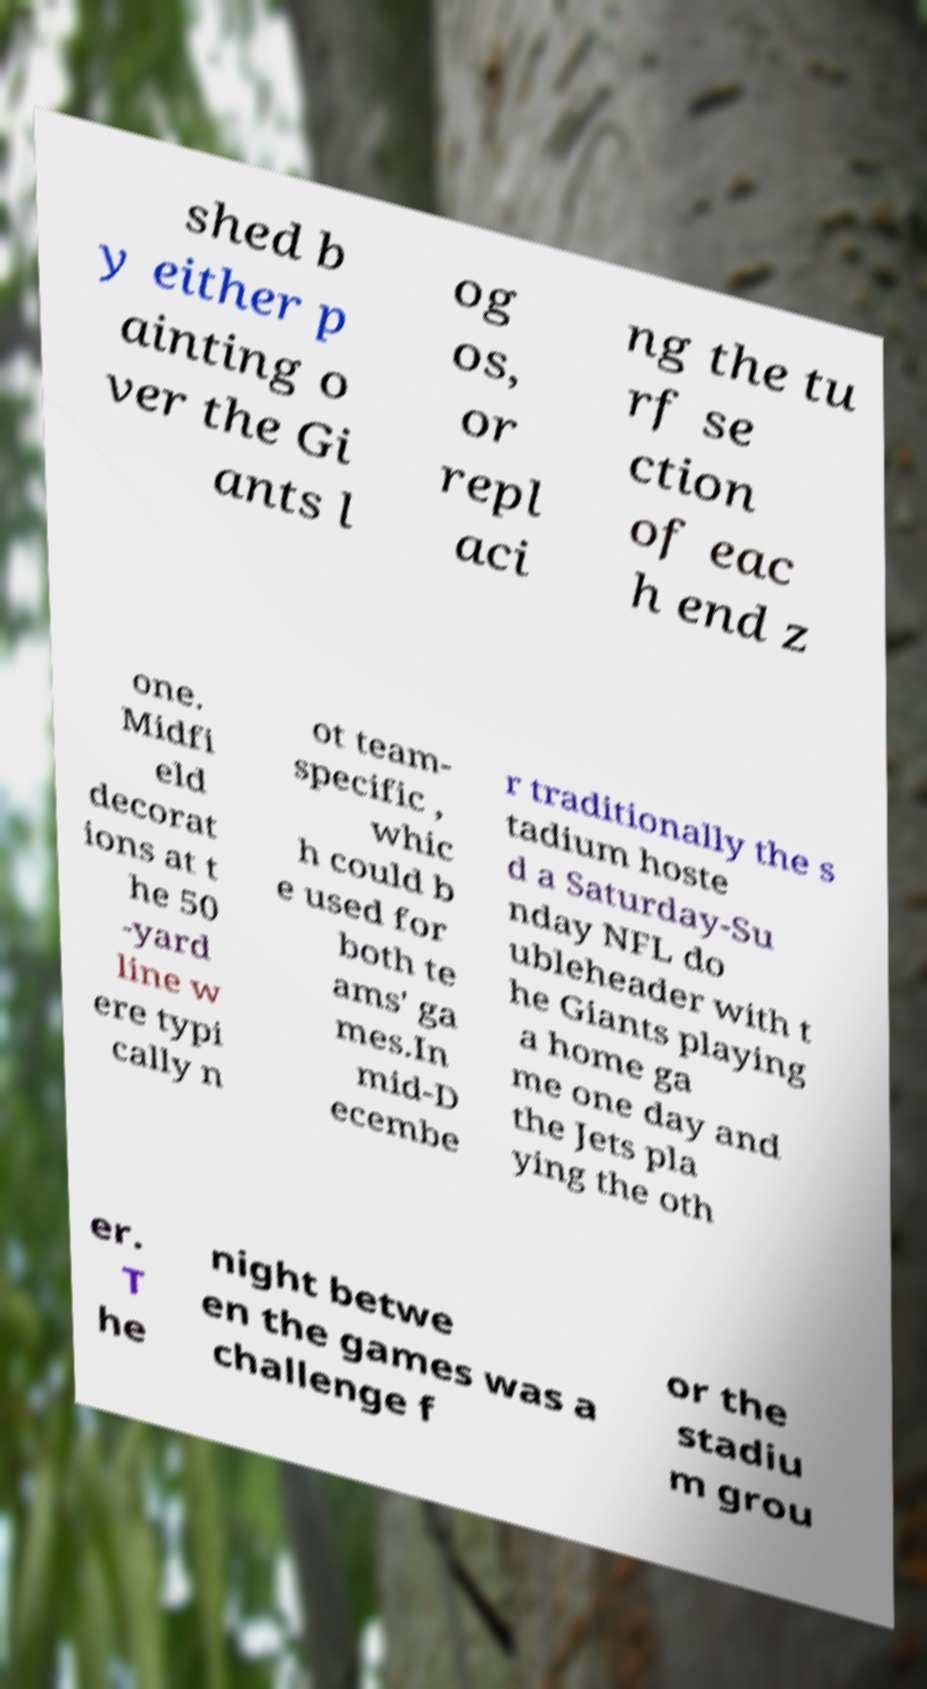Please read and relay the text visible in this image. What does it say? shed b y either p ainting o ver the Gi ants l og os, or repl aci ng the tu rf se ction of eac h end z one. Midfi eld decorat ions at t he 50 -yard line w ere typi cally n ot team- specific , whic h could b e used for both te ams' ga mes.In mid-D ecembe r traditionally the s tadium hoste d a Saturday-Su nday NFL do ubleheader with t he Giants playing a home ga me one day and the Jets pla ying the oth er. T he night betwe en the games was a challenge f or the stadiu m grou 